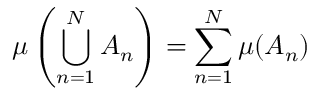<formula> <loc_0><loc_0><loc_500><loc_500>\mu \left ( \bigcup _ { n = 1 } ^ { N } A _ { n } \right ) = \sum _ { n = 1 } ^ { N } \mu ( A _ { n } )</formula> 